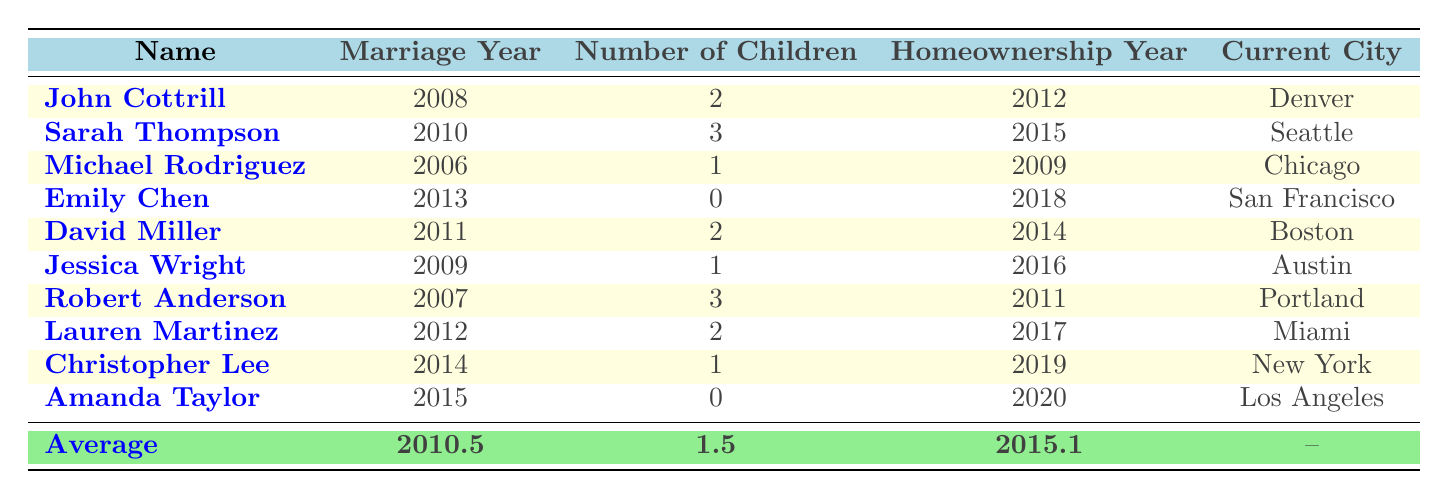What year did John Cottrill get married? John Cottrill's Marriage Year is given directly in the table as 2008.
Answer: 2008 How many children does Sarah Thompson have? The Number of Children for Sarah Thompson is listed in the table as 3.
Answer: 3 What is the average number of children among the group? To find the average number of children, sum the children (2 + 3 + 1 + 0 + 2 + 1 + 3 + 2 + 1 + 0) = 15. Divide by the number of people (10), so the average is 15/10 = 1.5.
Answer: 1.5 Is Lauren Martinez a homeowner? Lauren Martinez has a listed Homeownership Year of 2017, thus she is indeed a homeowner.
Answer: Yes Which city has the person with the maximum number of children, and how many children do they have? Looking at the table, Robert Anderson has the maximum number of children, which is 3. His current city is Portland. Thus, the answer is Portland, 3.
Answer: Portland, 3 What is the difference in years between the marriage of John Cottrill and Amanda Taylor? John Cottrill was married in 2008 and Amanda Taylor in 2015. The difference is 2015 - 2008 = 7 years.
Answer: 7 Which individual has the most recent homeownership year, and what year was it? The most recent Homeownership Year listed is for Amanda Taylor, who became a homeowner in 2020.
Answer: Amanda Taylor, 2020 Did everyone in the group have children? By reviewing the Number of Children column, both Emily Chen and Amanda Taylor have 0 children, which indicates that not everyone had children.
Answer: No How many people got married before 2010? The Marriage Years before 2010 are those of Michael Rodriguez (2006), John Cottrill (2008), and Robert Anderson (2007), totaling 3 individuals.
Answer: 3 